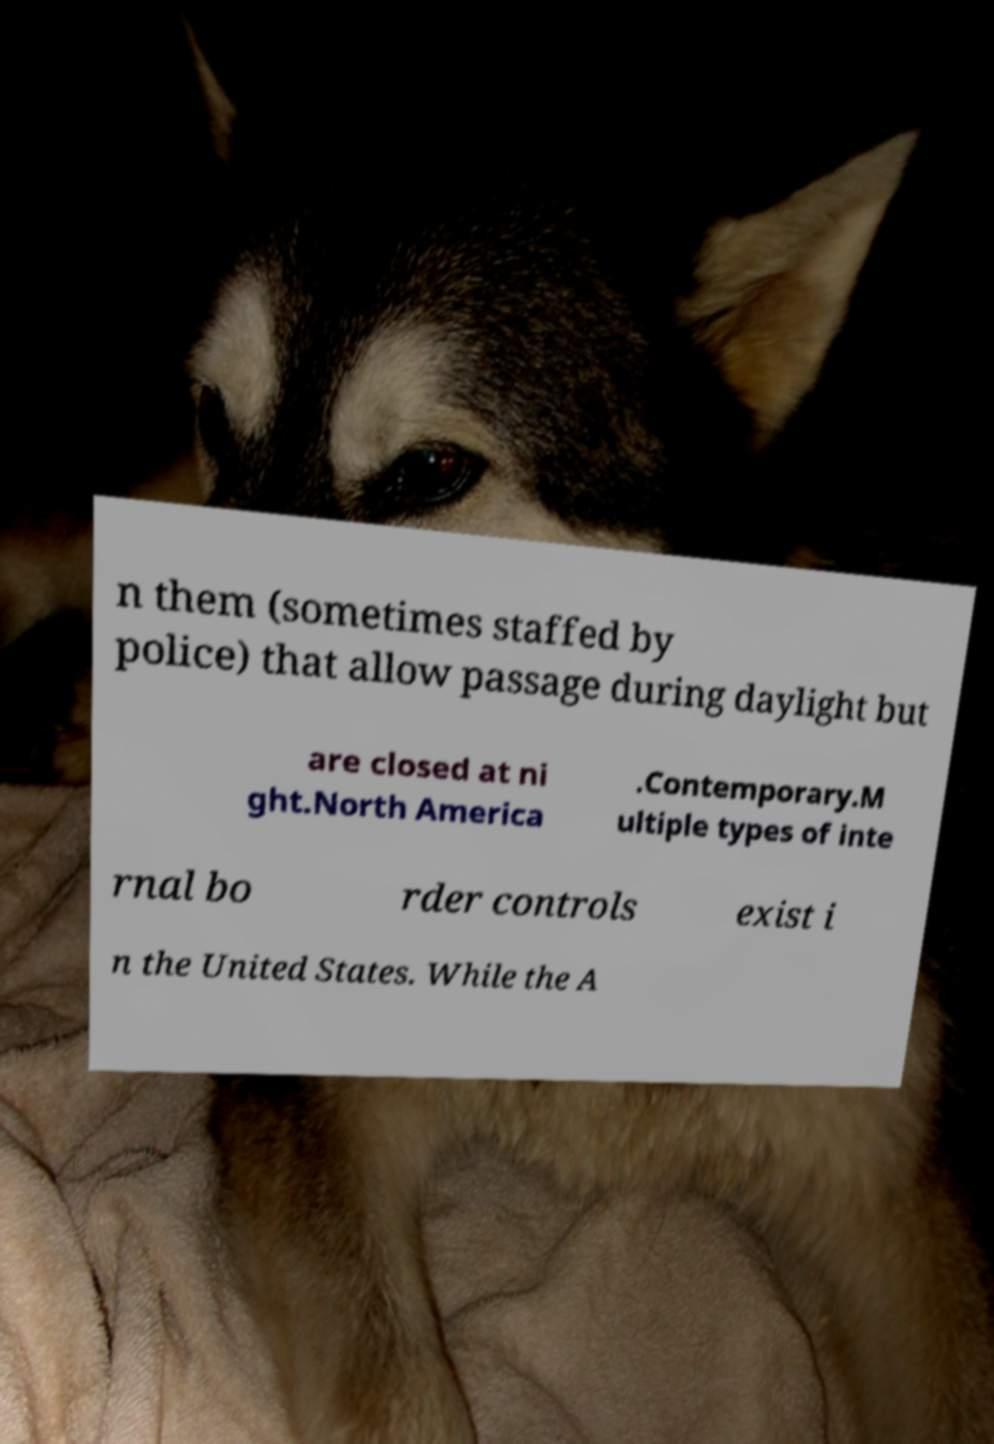What messages or text are displayed in this image? I need them in a readable, typed format. n them (sometimes staffed by police) that allow passage during daylight but are closed at ni ght.North America .Contemporary.M ultiple types of inte rnal bo rder controls exist i n the United States. While the A 